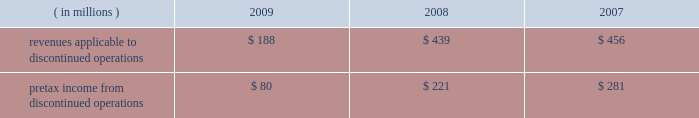Marathon oil corporation notes to consolidated financial statements been reported as discontinued operations in the consolidated statements of income and the consolidated statements of cash flows for all periods presented .
Discontinued operations 2014revenues and pretax income associated with our discontinued irish and gabonese operations are shown in the table : ( in millions ) 2009 2008 2007 .
Angola disposition 2013 in july 2009 , we entered into an agreement to sell an undivided 20 percent outside- operated interest in the production sharing contract and joint operating agreement in block 32 offshore angola for $ 1.3 billion , excluding any purchase price adjustments at closing , with an effective date of january 1 , 2009 .
The sale closed and we received net proceeds of $ 1.3 billion in february 2010 .
The pretax gain on the sale will be approximately $ 800 million .
We retained a 10 percent outside-operated interest in block 32 .
Gabon disposition 2013 in december 2009 , we closed the sale of our operated fields offshore gabon , receiving net proceeds of $ 269 million , after closing adjustments .
A $ 232 million pretax gain on this disposition was reported in discontinued operations for 2009 .
Permian basin disposition 2013 in june 2009 , we closed the sale of our operated and a portion of our outside- operated permian basin producing assets in new mexico and west texas for net proceeds after closing adjustments of $ 293 million .
A $ 196 million pretax gain on the sale was recorded .
Ireland dispositions 2013 in april 2009 , we closed the sale of our operated properties in ireland for net proceeds of $ 84 million , after adjusting for cash held by the sold subsidiary .
A $ 158 million pretax gain on the sale was recorded .
As a result of this sale , we terminated our pension plan in ireland , incurring a charge of $ 18 million .
In june 2009 , we entered into an agreement to sell the subsidiary holding our 19 percent outside-operated interest in the corrib natural gas development offshore ireland .
Total proceeds were estimated to range between $ 235 million and $ 400 million , subject to the timing of first commercial gas at corrib and closing adjustments .
At closing on july 30 , 2009 , the initial $ 100 million payment plus closing adjustments was received .
The fair value of the proceeds was estimated to be $ 311 million .
Fair value of anticipated sale proceeds includes ( i ) $ 100 million received at closing , ( ii ) $ 135 million minimum amount due at the earlier of first gas or december 31 , 2012 , and ( iii ) a range of zero to $ 165 million of contingent proceeds subject to the timing of first commercial gas .
A $ 154 million impairment of the held for sale asset was recognized in discontinued operations in the second quarter of 2009 ( see note 16 ) since the fair value of the disposal group was less than the net book value .
Final proceeds will range between $ 135 million ( minimum amount ) to $ 300 million and are due on the earlier of first commercial gas or december 31 , 2012 .
The fair value of the expected final proceeds was recorded as an asset at closing .
As a result of new public information in the fourth quarter of 2009 , a writeoff was recorded on the contingent portion of the proceeds ( see note 10 ) .
Existing guarantees of our subsidiaries 2019 performance issued to irish government entities will remain in place after the sales until the purchasers issue similar guarantees to replace them .
The guarantees , related to asset retirement obligations and natural gas production levels , have been indemnified by the purchasers .
The fair value of these guarantees is not significant .
Norwegian disposition 2013 on october 31 , 2008 , we closed the sale of our norwegian outside-operated e&p properties and undeveloped offshore acreage in the heimdal area of the norwegian north sea for net proceeds of $ 301 million , with a pretax gain of $ 254 million as of december 31 , 2008 .
Pilot travel centers disposition 2013 on october 8 , 2008 , we completed the sale of our 50 percent ownership interest in ptc .
Sale proceeds were $ 625 million , with a pretax gain on the sale of $ 126 million .
Immediately preceding the sale , we received a $ 75 million partial redemption of our ownership interest from ptc that was accounted for as a return of investment .
This was an investment of our rm&t segment. .
What was the lowest yearly revenues applicable to discontinued operations? 
Computations: table_min(revenues applicable to discontinued operations, none)
Answer: 188.0. 